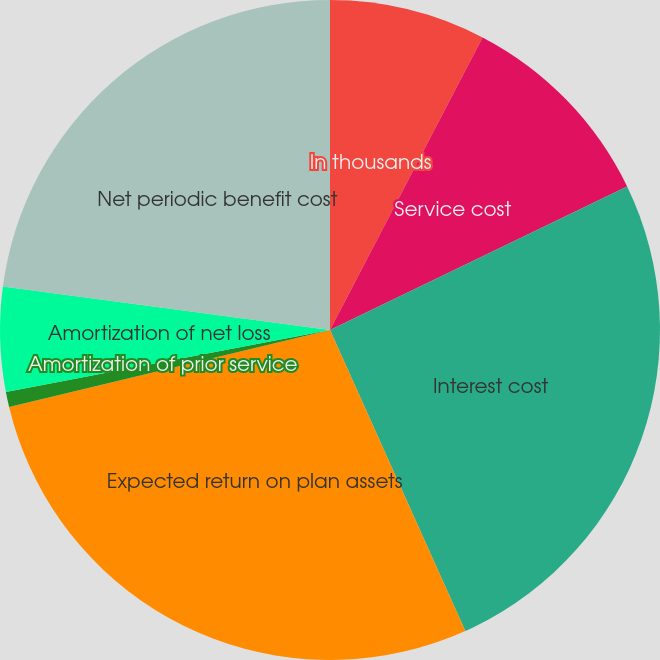Convert chart to OTSL. <chart><loc_0><loc_0><loc_500><loc_500><pie_chart><fcel>In thousands<fcel>Service cost<fcel>Interest cost<fcel>Expected return on plan assets<fcel>Amortization of prior service<fcel>Amortization of net loss<fcel>Net periodic benefit cost<nl><fcel>7.65%<fcel>10.19%<fcel>25.44%<fcel>27.98%<fcel>0.74%<fcel>5.11%<fcel>22.9%<nl></chart> 